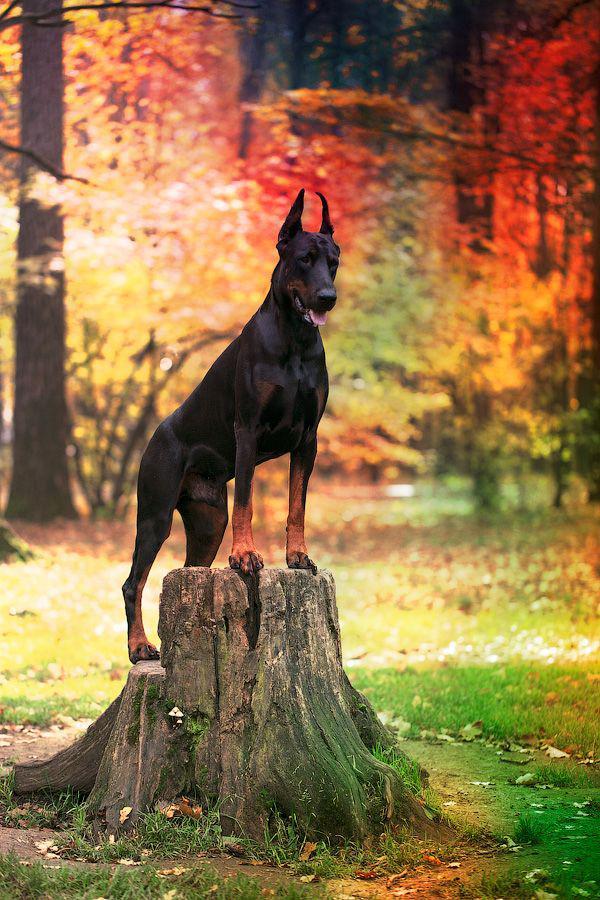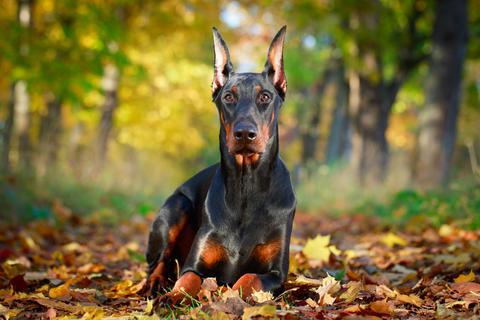The first image is the image on the left, the second image is the image on the right. Examine the images to the left and right. Is the description "Each image contains one erect-eared doberman posed outdoors, and one image shows a standing dog with front feet elevated and body turned rightward in front of autumn colors." accurate? Answer yes or no. Yes. The first image is the image on the left, the second image is the image on the right. Assess this claim about the two images: "A dog is outside near a building in one of the buildings.". Correct or not? Answer yes or no. No. 